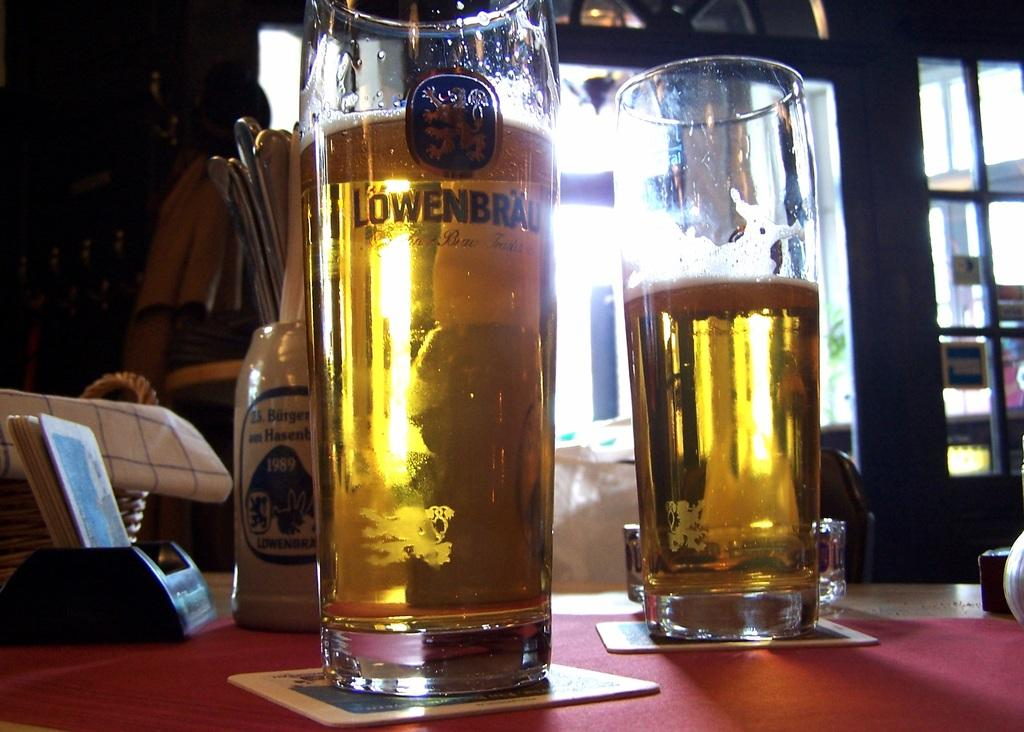<image>
Relay a brief, clear account of the picture shown. Two Lowenbrau glasses filled with beer sitting on a table. 